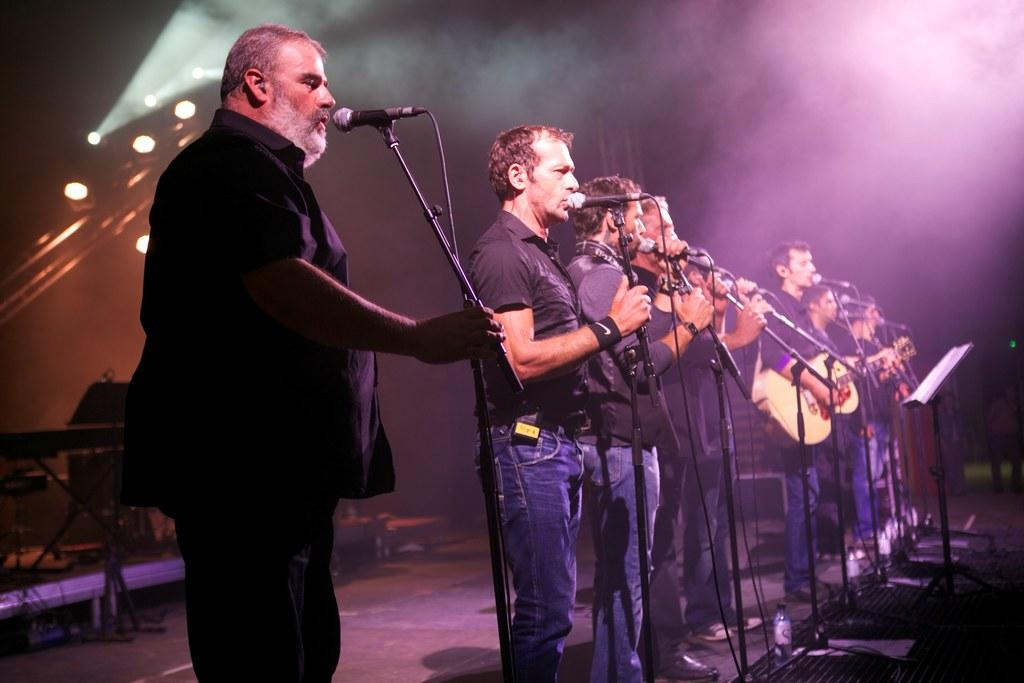How many people are in the image? There are many people in the image. What are the people doing in the image? The people are standing in a row and singing on a stage. What can be seen in front of the people? The people are in front of mics and stands. What is visible in the background of the image? There is smoke and lights in the background of the image. What type of chin can be seen on the slope in the image? There is no chin or slope present in the image; it features a group of people singing on a stage. 